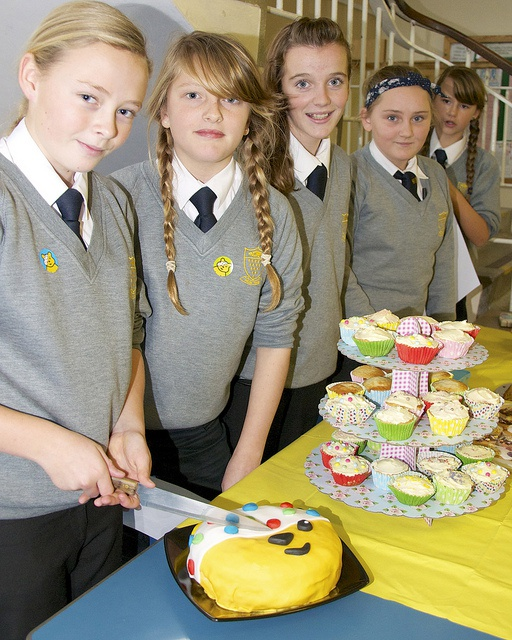Describe the objects in this image and their specific colors. I can see dining table in lightgray, khaki, and gray tones, people in lightgray, darkgray, black, and tan tones, people in lightgray, darkgray, black, and tan tones, people in lightgray, gray, black, tan, and olive tones, and people in lightgray, gray, and black tones in this image. 